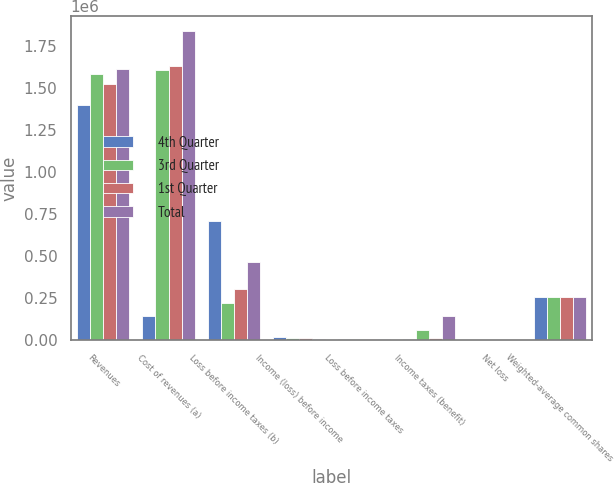<chart> <loc_0><loc_0><loc_500><loc_500><stacked_bar_chart><ecel><fcel>Revenues<fcel>Cost of revenues (a)<fcel>Loss before income taxes (b)<fcel>Income (loss) before income<fcel>Loss before income taxes<fcel>Income taxes (benefit)<fcel>Net loss<fcel>Weighted-average common shares<nl><fcel>4th Quarter<fcel>1.39811e+06<fcel>141560<fcel>705130<fcel>15044<fcel>2970<fcel>3088<fcel>2.75<fcel>253166<nl><fcel>3rd Quarter<fcel>1.58047e+06<fcel>1.60539e+06<fcel>221321<fcel>10802<fcel>4708<fcel>56810<fcel>0.63<fcel>253454<nl><fcel>1st Quarter<fcel>1.52179e+06<fcel>1.62697e+06<fcel>301966<fcel>10092<fcel>2717<fcel>14204<fcel>1.11<fcel>253582<nl><fcel>Total<fcel>1.61167e+06<fcel>1.83681e+06<fcel>466294<fcel>7893<fcel>5538<fcel>141560<fcel>1.33<fcel>253841<nl></chart> 